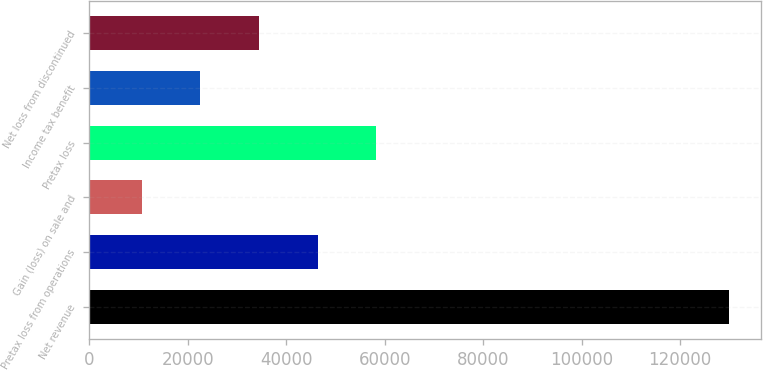<chart> <loc_0><loc_0><loc_500><loc_500><bar_chart><fcel>Net revenue<fcel>Pretax loss from operations<fcel>Gain (loss) on sale and<fcel>Pretax loss<fcel>Income tax benefit<fcel>Net loss from discontinued<nl><fcel>129863<fcel>46397.1<fcel>10626<fcel>58320.8<fcel>22549.7<fcel>34473.4<nl></chart> 